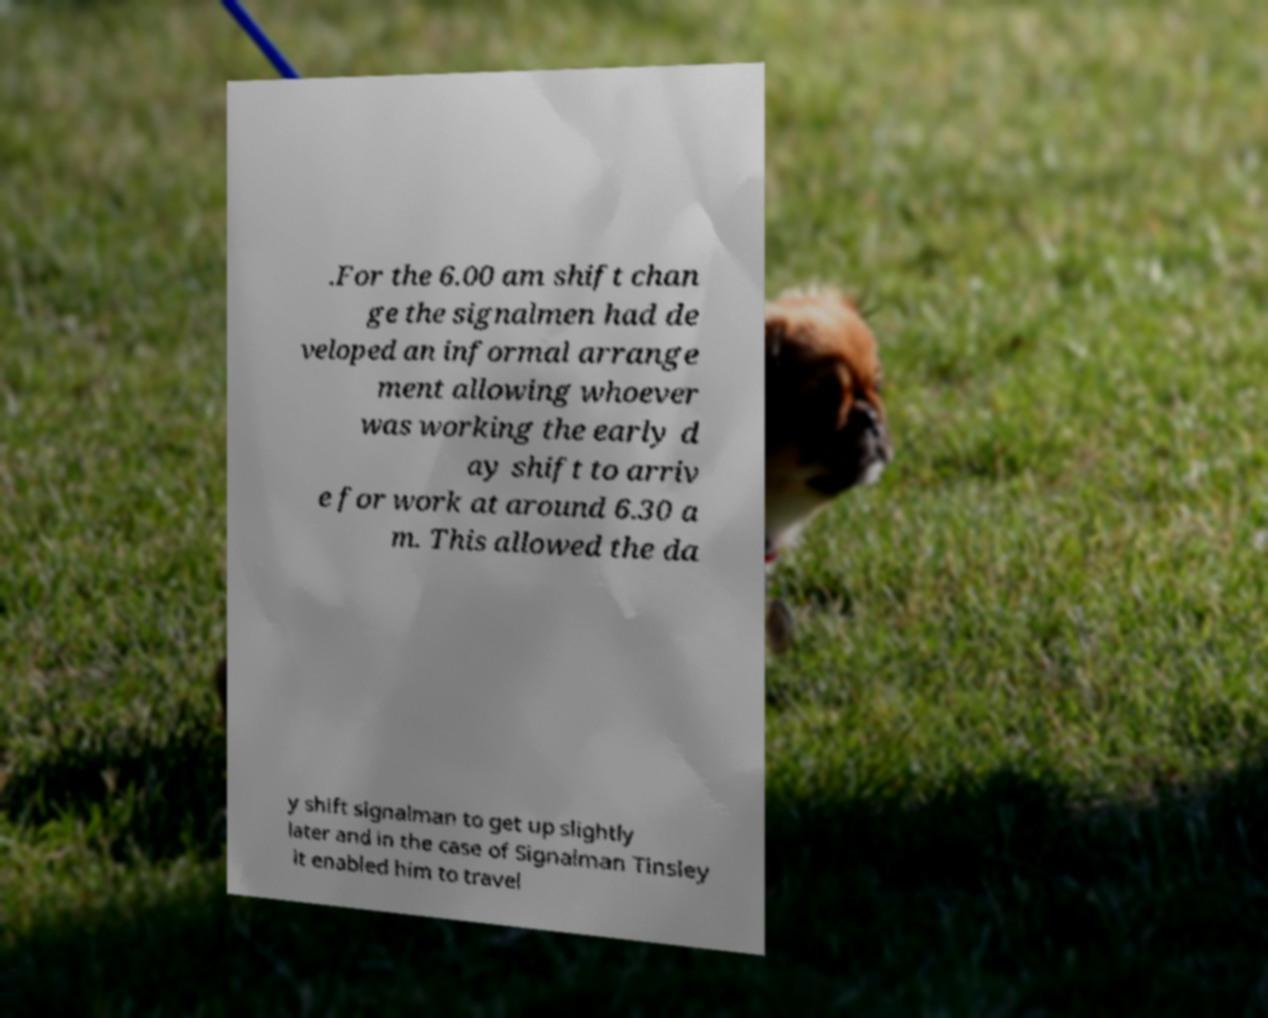I need the written content from this picture converted into text. Can you do that? .For the 6.00 am shift chan ge the signalmen had de veloped an informal arrange ment allowing whoever was working the early d ay shift to arriv e for work at around 6.30 a m. This allowed the da y shift signalman to get up slightly later and in the case of Signalman Tinsley it enabled him to travel 